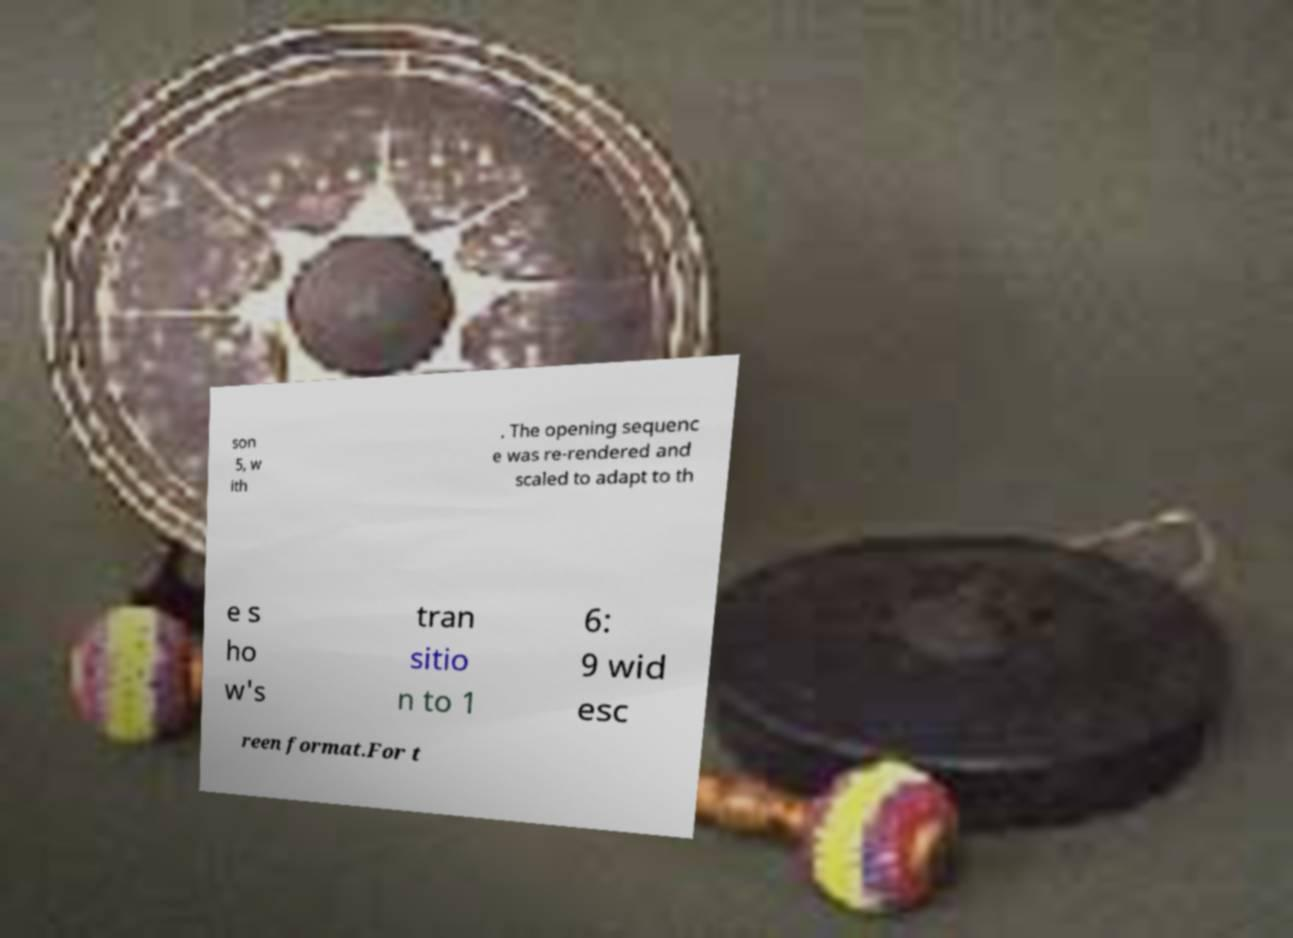What messages or text are displayed in this image? I need them in a readable, typed format. son 5, w ith . The opening sequenc e was re-rendered and scaled to adapt to th e s ho w's tran sitio n to 1 6: 9 wid esc reen format.For t 